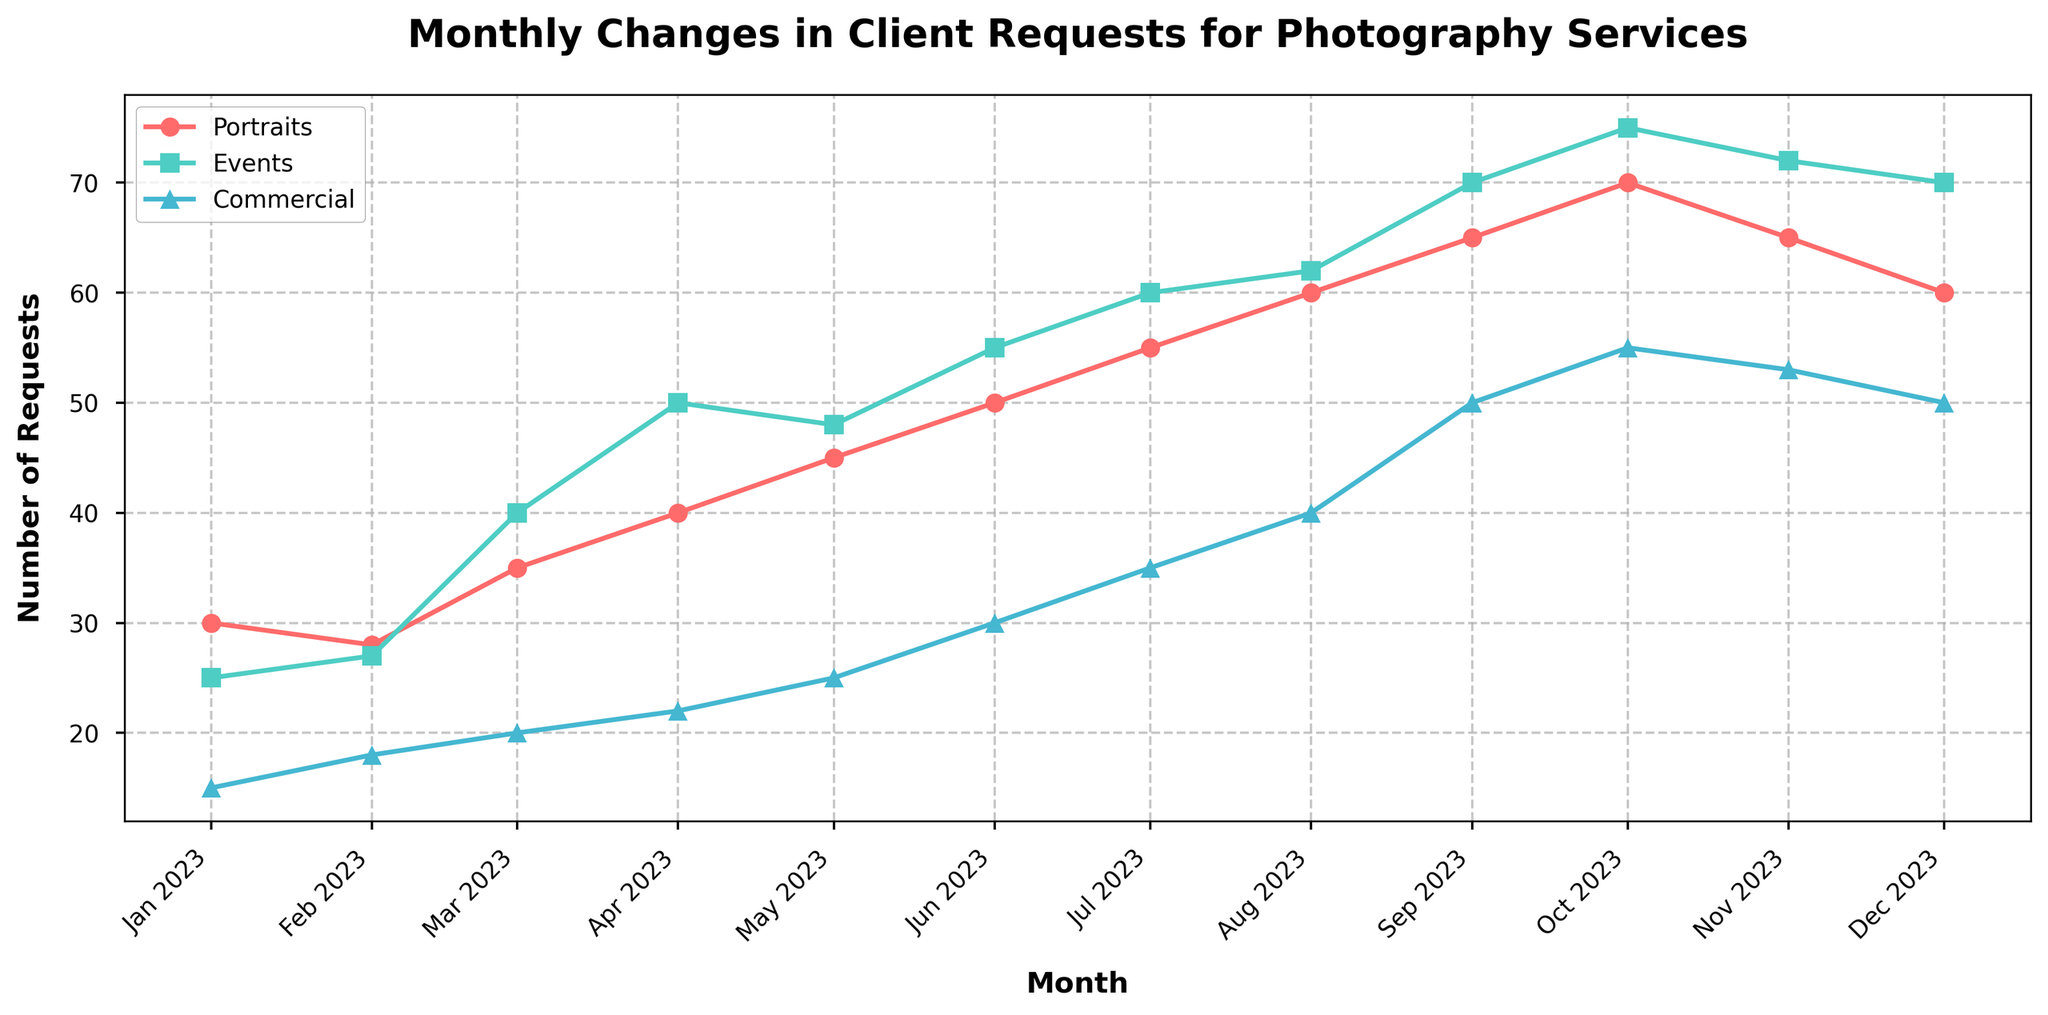What is the title of the figure? The title is usually located at the top of the figure. In this figure, the title is "Monthly Changes in Client Requests for Photography Services."
Answer: Monthly Changes in Client Requests for Photography Services Which month had the highest number of client requests for Commercial photography services? The Commercial service is represented by the blue line with triangle markers. The highest point on this line is in October, with 55 requests.
Answer: October How many client requests were there for Portraits in March? The Portraits service is represented by the red line with circle markers. In March, the data point shows 35 requests.
Answer: 35 What is the difference in the number of client requests for Events between July and November? The Events service is represented by the green line with square markers. In July, there were 60 requests, and in November, there were 72 requests. The difference is 72 - 60 = 12.
Answer: 12 How did the number of client requests for Portraits change from January to December? The Portraits service had 30 requests in January and 60 requests in December. The change is 60 - 30 = 30.
Answer: Increased by 30 Which photography service experienced the most significant increase in requests from January to December? To find this, compare the changes of all three services. Portraits increased from 30 to 60 (30 requests), Events increased from 25 to 70 (45 requests), and Commercial increased from 15 to 50 (35 requests). Events had the most significant increase of 45 requests.
Answer: Events What month had the peak number of total requests for all three services combined? To find the highest total, sum the number of requests for all services each month. September has the peak with 65 (Portraits) + 70 (Events) + 50 (Commercial) = 185 requests.
Answer: September What is the average number of client requests for Events over the year? Sum the number of requests for Events across all months: 25 + 27 + 40 + 50 + 48 + 55 + 60 + 62 + 70 + 75 + 72 + 70 = 654. Divide by 12 months to get 654 / 12 ≈ 54.5.
Answer: 54.5 Between which consecutive months did Commercial photography services experience the largest drop in requests? Examine the blue line with triangle markers for drops between months. The largest drop is between October (55) and November (53) with a difference of 55 - 53 = 2.
Answer: October to November What was the overall trend for client requests for Portraits throughout the year? The red line with circle markers shows a generally increasing trend throughout the year, peaking in October before slightly declining towards December.
Answer: Increasing with a peak in October 